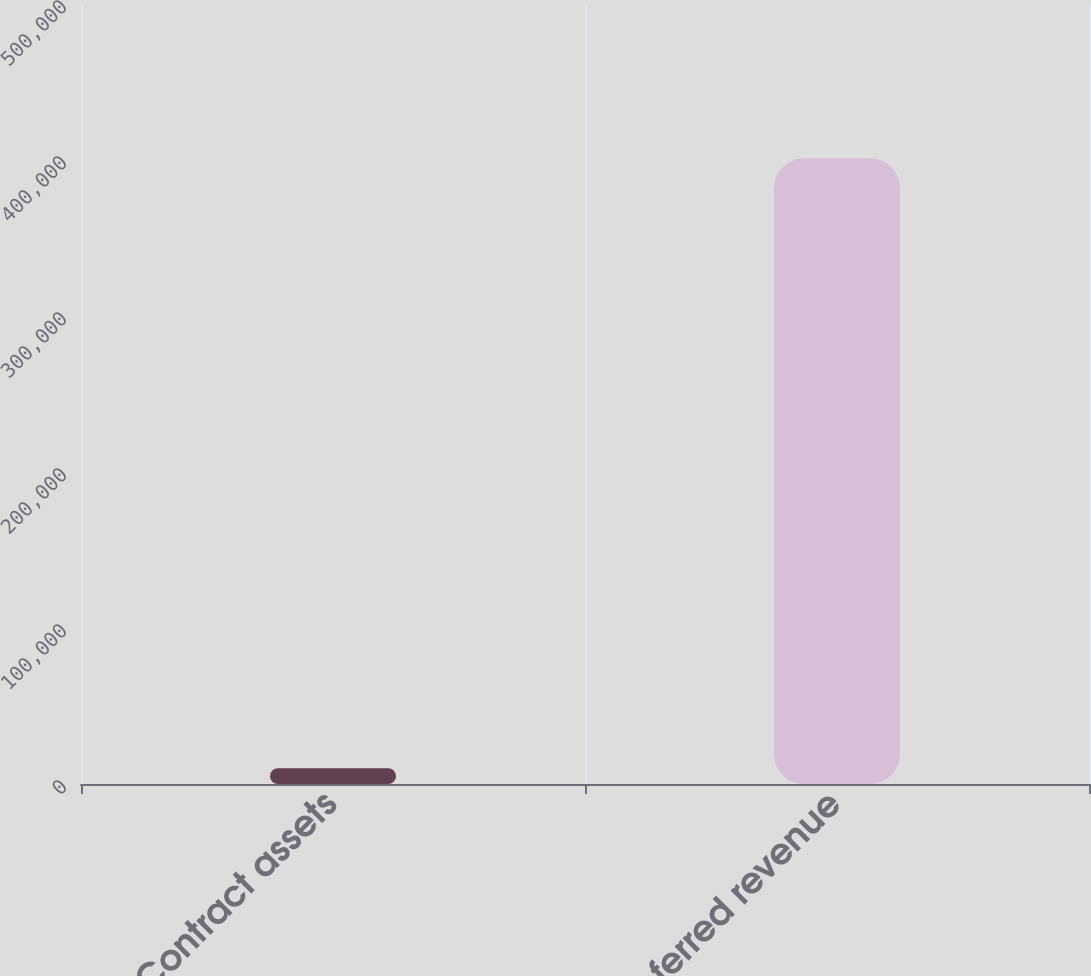Convert chart. <chart><loc_0><loc_0><loc_500><loc_500><bar_chart><fcel>Contract assets<fcel>Deferred revenue<nl><fcel>10055<fcel>401174<nl></chart> 